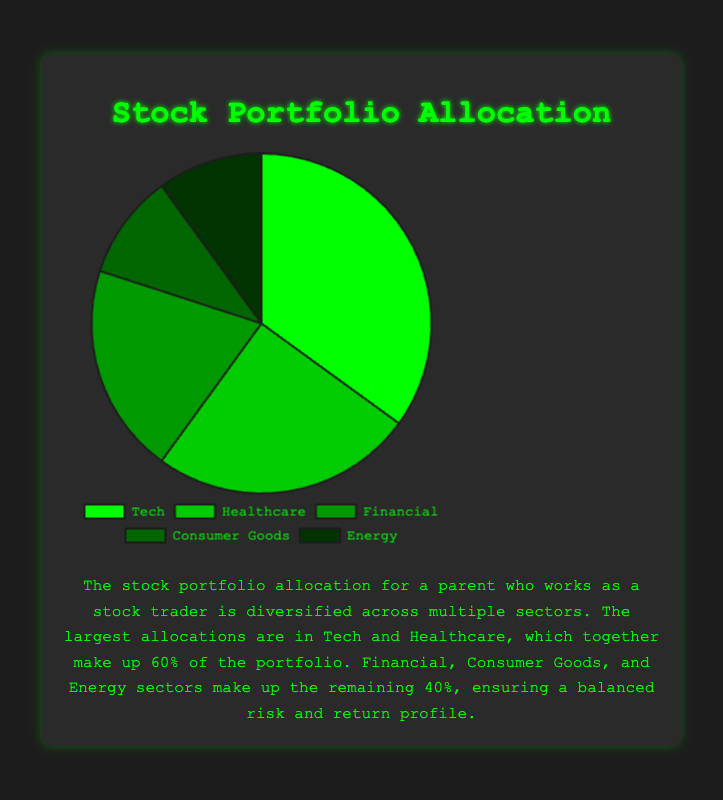What sectors make up 60% of the portfolio? According to the figure, Tech at 35% and Healthcare at 25% together make up 60% of the portfolio. Adding their percentages, 35% + 25% = 60%.
Answer: Tech and Healthcare Which sector has the highest allocation? The figure shows that Tech has the largest slice, indicating the highest allocation at 35%.
Answer: Tech What is the total percentage allocated to Consumer Goods and Energy combined? The figure shows Consumer Goods at 10% and Energy at 10%. Adding these together gives 10% + 10% = 20%.
Answer: 20% How does the allocation of Financial compare to Healthcare? The figure shows Financial at 20% and Healthcare at 25%. Financial is 5% less than Healthcare.
Answer: Financial is 5% less Which two sectors together form a quarter of the portfolio's allocation? If you look at Consumer Goods and Energy, each 10%, adding both yields 20% or one-fifth. Including Financial with one more allocation of 20% would not work as its too much.
Answer: There is no combination that sums exactly to a quarter Among the sectors, which have an equal allocation and what is that allocation? From the figure, both Consumer Goods and Energy have equal allocations at 10% each.
Answer: Consumer Goods and Energy at 10% What is the second-largest sector in the portfolio? The figure shows the second-largest slice is Healthcare at 25%.
Answer: Healthcare By how much does the Tech sector exceed the Financial sector in percentage terms? The figure shows Tech at 35% and Financial at 20%. The difference is 35% - 20% = 15%.
Answer: 15% Calculate the average percentage allocation of all sectors. Adding all allocations: 35% (Tech) + 25% (Healthcare) + 20% (Financial) + 10% (Consumer Goods) + 10% (Energy) = 100%. Since there are 5 sectors, the average is 100% / 5 = 20%.
Answer: 20% What color represents the Financial sector on the pie chart? The figure uses distinct colors for each sector and indicates that the Financial sector is represented by a shade of green.
Answer: A shade of green 